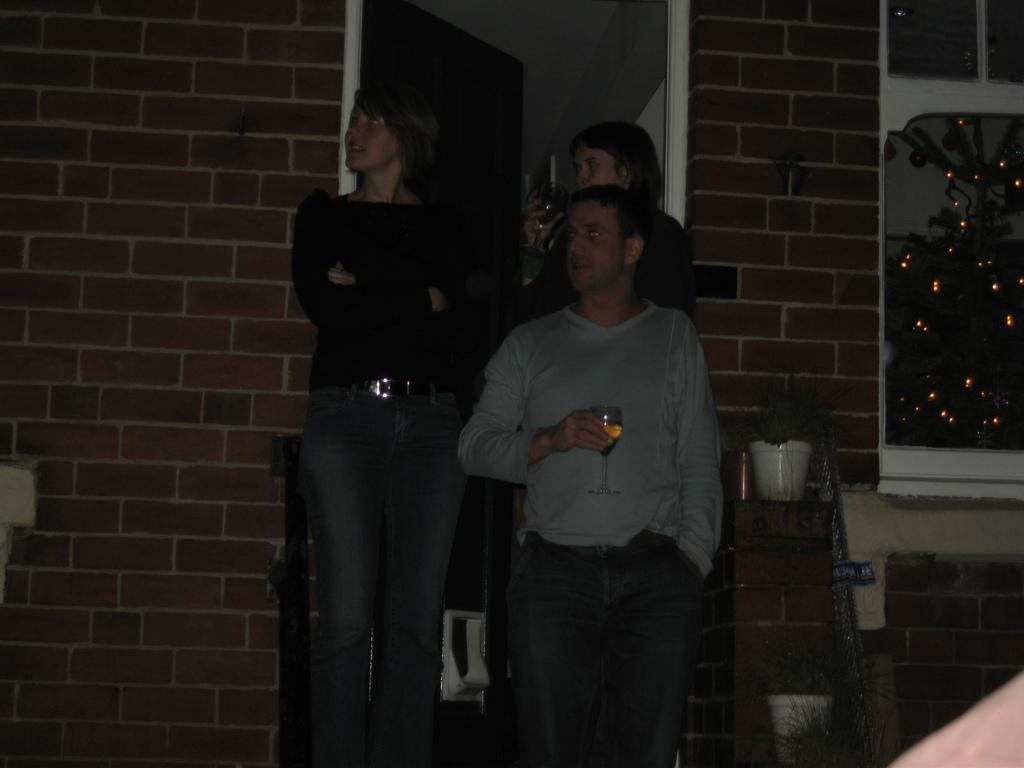How many people are in the image? There are three persons in the image. What are the persons holding in their hands? Each person is holding a glass of drink. Where are the persons standing in relation to the door? The persons are standing in front of a door. What can be seen in the image besides the people and the door? There is a plant pot and a wall with red bricks in the image. What type of food is being served on the side in the image? There is no food present in the image, and no serving is taking place on the side. 